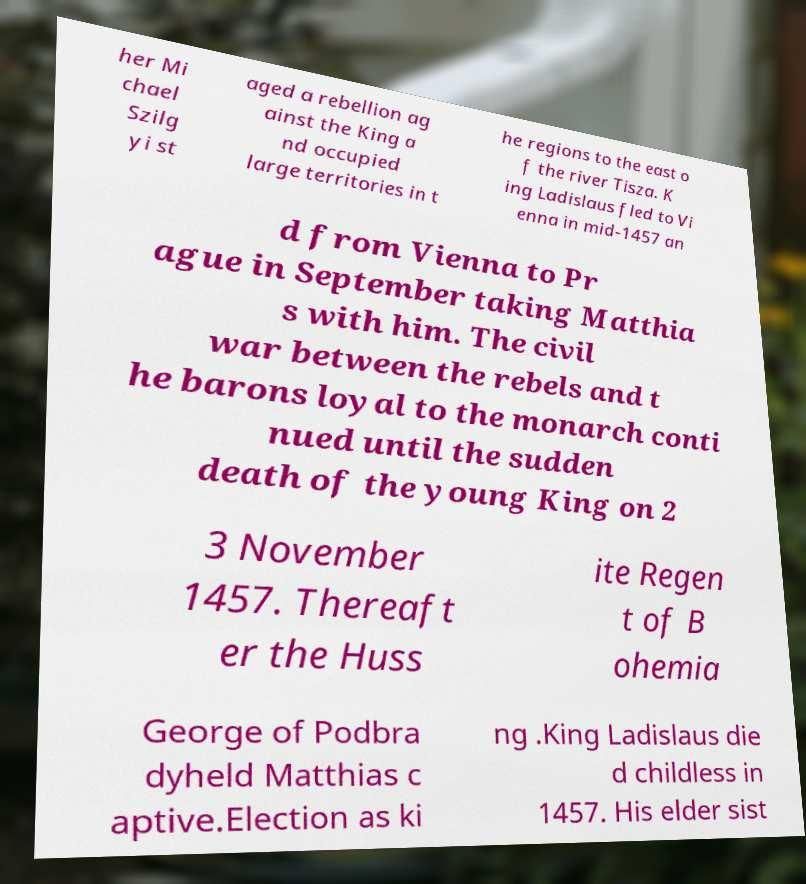For documentation purposes, I need the text within this image transcribed. Could you provide that? her Mi chael Szilg yi st aged a rebellion ag ainst the King a nd occupied large territories in t he regions to the east o f the river Tisza. K ing Ladislaus fled to Vi enna in mid-1457 an d from Vienna to Pr ague in September taking Matthia s with him. The civil war between the rebels and t he barons loyal to the monarch conti nued until the sudden death of the young King on 2 3 November 1457. Thereaft er the Huss ite Regen t of B ohemia George of Podbra dyheld Matthias c aptive.Election as ki ng .King Ladislaus die d childless in 1457. His elder sist 